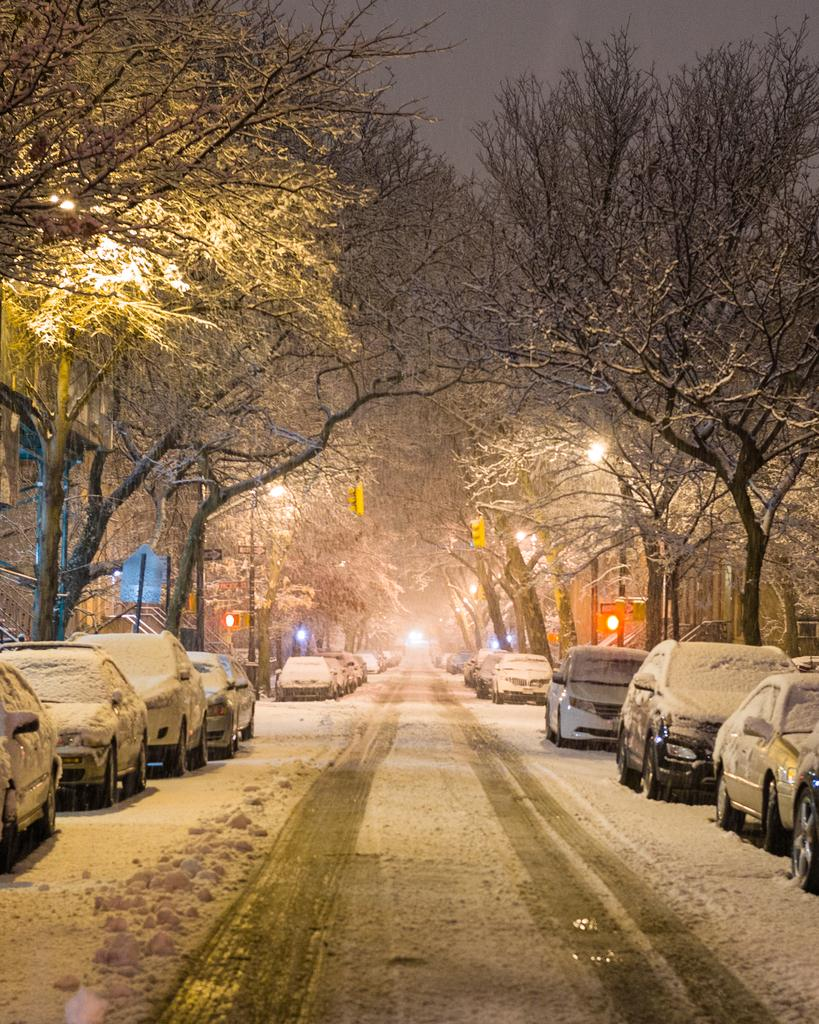What type of natural elements can be seen in the image? There are trees in the image. What man-made structures are present in the image? There are poles, lights, railings, buildings, and vehicles in the image. How is the image affected by the weather? All of these elements are covered by snow. What is at the bottom of the image? There is a road at the bottom of the image. What part of the natural environment is visible in the image? The sky is visible at the top of the image. What does the face of the person in the image say about the caption? There is no person or caption present in the image; it features a snow-covered scene with trees, poles, lights, railings, buildings, vehicles, a road, and sky. What type of season is depicted in the image? The image depicts a winter scene, as all elements are covered by snow. 